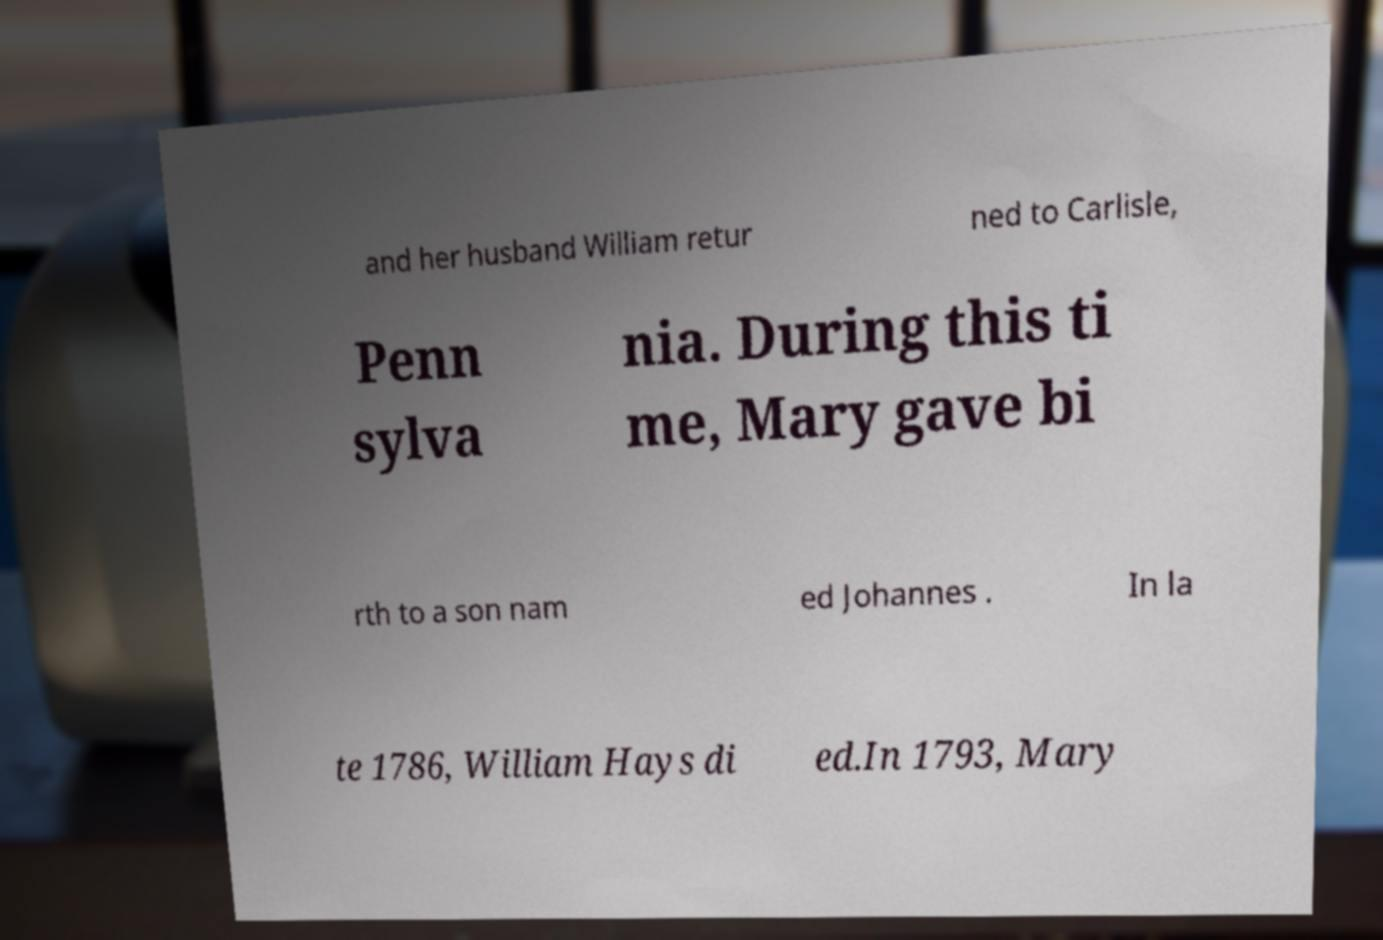Please identify and transcribe the text found in this image. and her husband William retur ned to Carlisle, Penn sylva nia. During this ti me, Mary gave bi rth to a son nam ed Johannes . In la te 1786, William Hays di ed.In 1793, Mary 